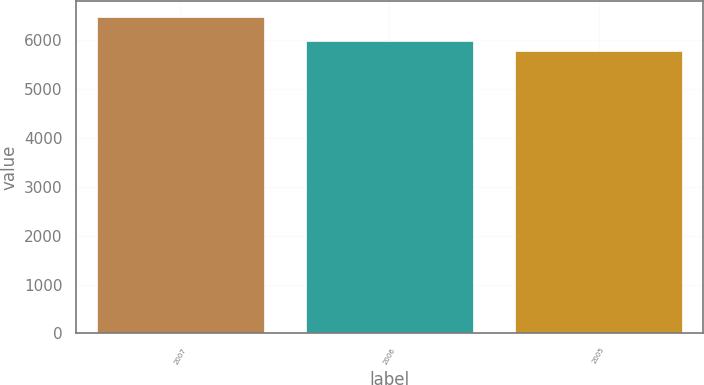Convert chart. <chart><loc_0><loc_0><loc_500><loc_500><bar_chart><fcel>2007<fcel>2006<fcel>2005<nl><fcel>6474.5<fcel>5982<fcel>5781.3<nl></chart> 